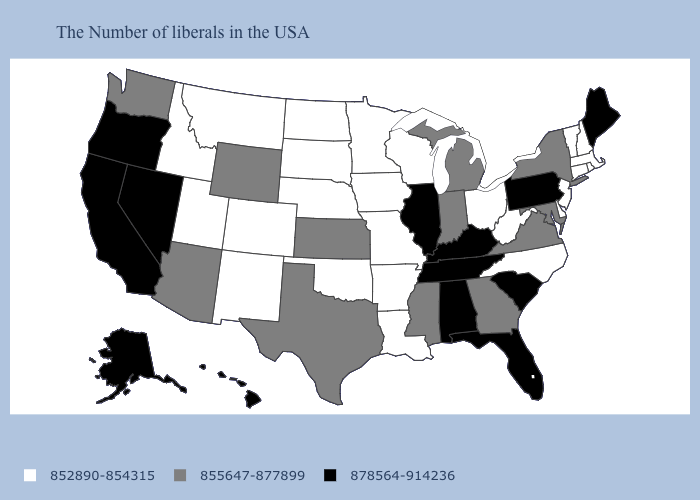Among the states that border Vermont , which have the lowest value?
Answer briefly. Massachusetts, New Hampshire. Among the states that border South Dakota , does Wyoming have the highest value?
Write a very short answer. Yes. What is the value of Minnesota?
Keep it brief. 852890-854315. Name the states that have a value in the range 855647-877899?
Keep it brief. New York, Maryland, Virginia, Georgia, Michigan, Indiana, Mississippi, Kansas, Texas, Wyoming, Arizona, Washington. Does Iowa have the highest value in the MidWest?
Answer briefly. No. Name the states that have a value in the range 852890-854315?
Short answer required. Massachusetts, Rhode Island, New Hampshire, Vermont, Connecticut, New Jersey, Delaware, North Carolina, West Virginia, Ohio, Wisconsin, Louisiana, Missouri, Arkansas, Minnesota, Iowa, Nebraska, Oklahoma, South Dakota, North Dakota, Colorado, New Mexico, Utah, Montana, Idaho. What is the value of Washington?
Concise answer only. 855647-877899. Name the states that have a value in the range 855647-877899?
Answer briefly. New York, Maryland, Virginia, Georgia, Michigan, Indiana, Mississippi, Kansas, Texas, Wyoming, Arizona, Washington. Does Michigan have the lowest value in the USA?
Answer briefly. No. Does Tennessee have the lowest value in the South?
Answer briefly. No. Name the states that have a value in the range 878564-914236?
Keep it brief. Maine, Pennsylvania, South Carolina, Florida, Kentucky, Alabama, Tennessee, Illinois, Nevada, California, Oregon, Alaska, Hawaii. Does Ohio have the lowest value in the MidWest?
Quick response, please. Yes. Which states have the highest value in the USA?
Write a very short answer. Maine, Pennsylvania, South Carolina, Florida, Kentucky, Alabama, Tennessee, Illinois, Nevada, California, Oregon, Alaska, Hawaii. Name the states that have a value in the range 878564-914236?
Answer briefly. Maine, Pennsylvania, South Carolina, Florida, Kentucky, Alabama, Tennessee, Illinois, Nevada, California, Oregon, Alaska, Hawaii. Name the states that have a value in the range 878564-914236?
Give a very brief answer. Maine, Pennsylvania, South Carolina, Florida, Kentucky, Alabama, Tennessee, Illinois, Nevada, California, Oregon, Alaska, Hawaii. 